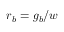Convert formula to latex. <formula><loc_0><loc_0><loc_500><loc_500>r _ { b } = g _ { b } / w</formula> 